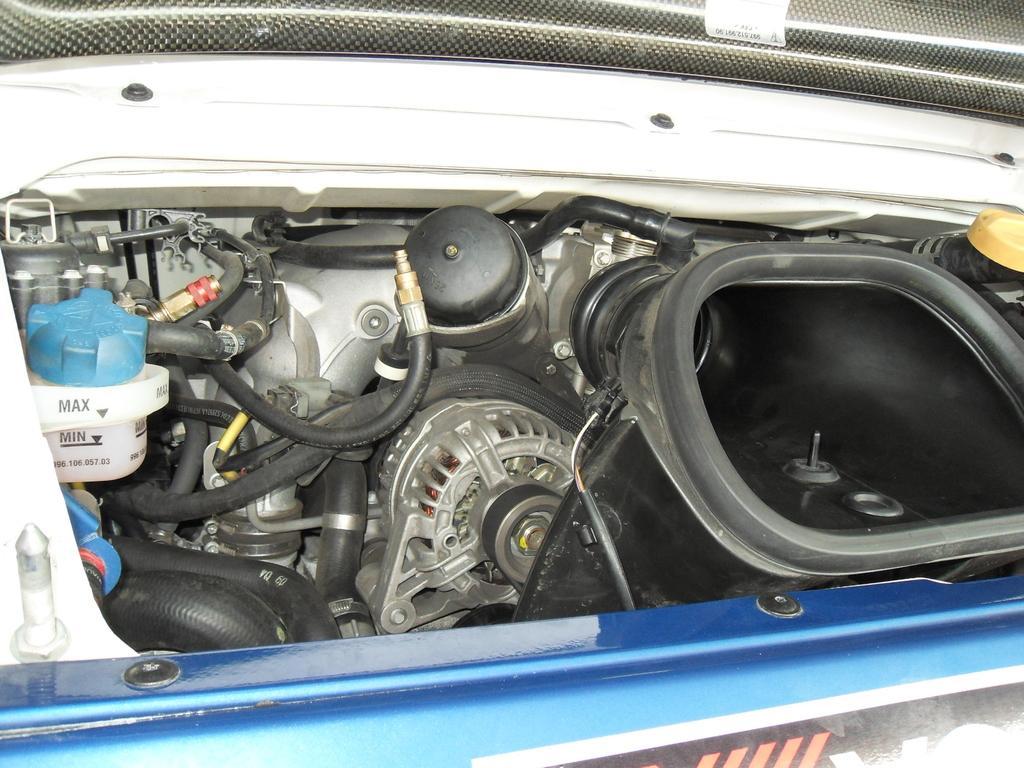Please provide a concise description of this image. In the image there is a coolant, black tubes, radiator and turbo box. At the bottom of the image there is a radiator grill. 